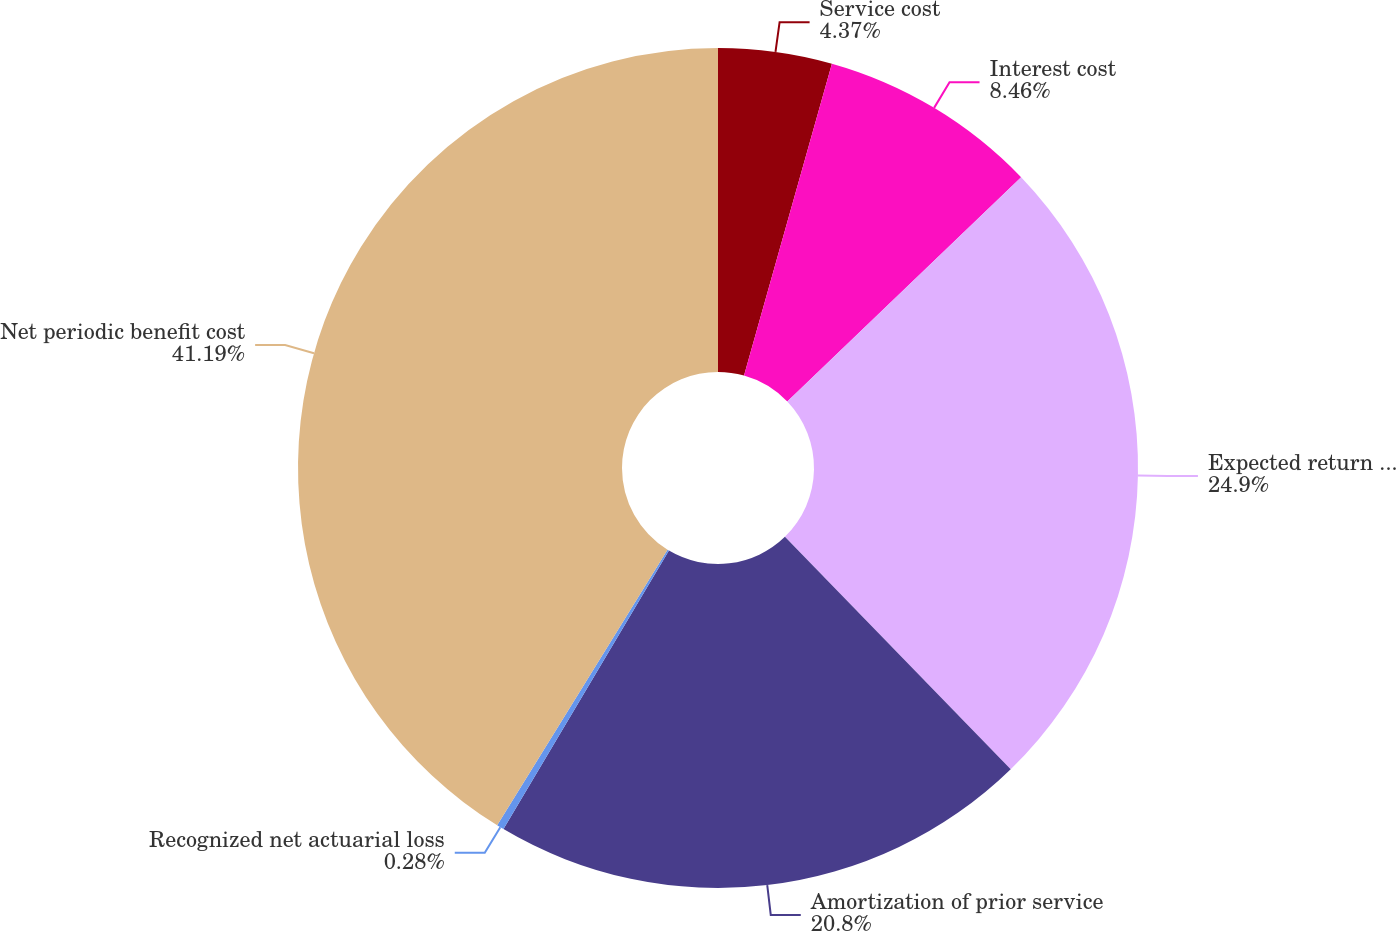Convert chart to OTSL. <chart><loc_0><loc_0><loc_500><loc_500><pie_chart><fcel>Service cost<fcel>Interest cost<fcel>Expected return on plan assets<fcel>Amortization of prior service<fcel>Recognized net actuarial loss<fcel>Net periodic benefit cost<nl><fcel>4.37%<fcel>8.46%<fcel>24.89%<fcel>20.8%<fcel>0.28%<fcel>41.18%<nl></chart> 